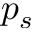Convert formula to latex. <formula><loc_0><loc_0><loc_500><loc_500>p _ { s }</formula> 